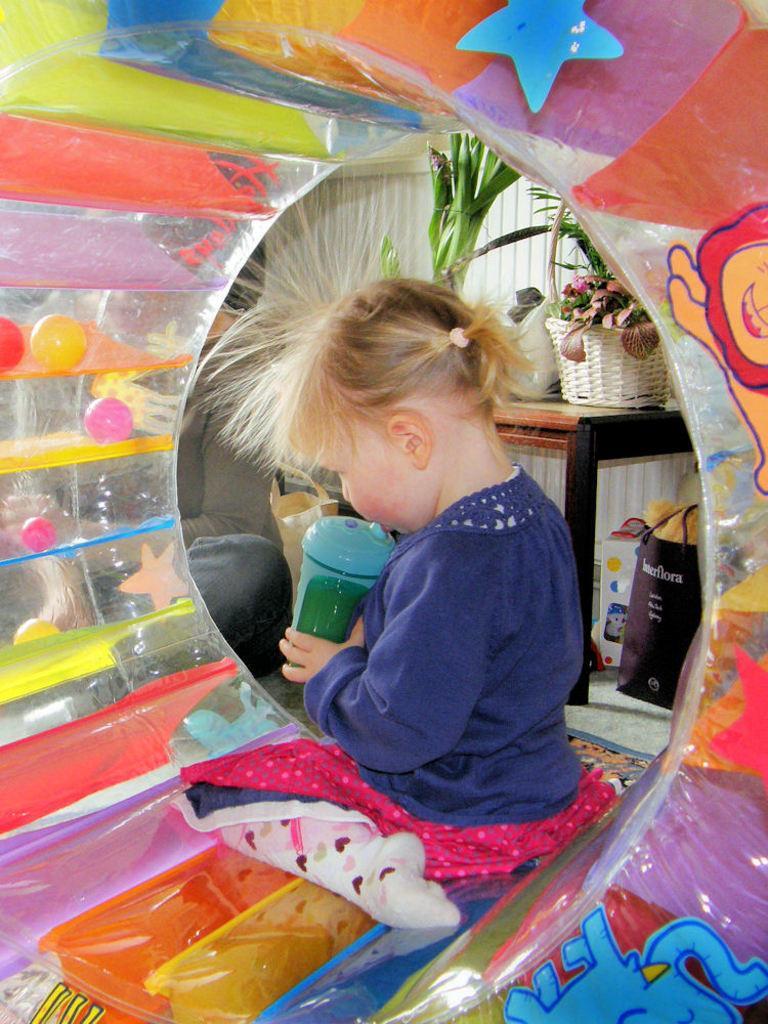How would you summarize this image in a sentence or two? This image is clicked inside a room. There is a ring shaped circular balloon in which a girl is sitting. The girl is wearing a blue and pink dress. She is also wearing socks. In the background, there is a table on which there are flower baskets and a plant. At the bottom there are bags in which some clothes are kept. 